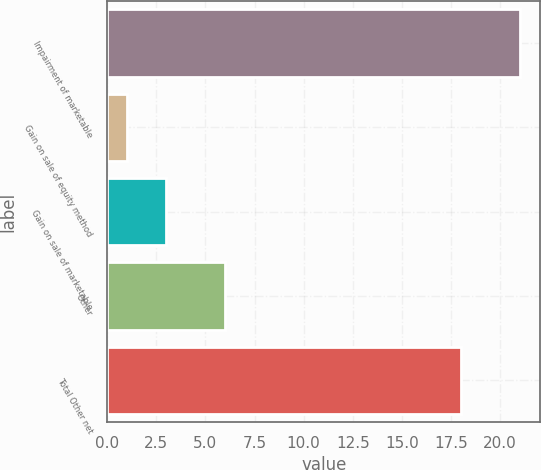Convert chart to OTSL. <chart><loc_0><loc_0><loc_500><loc_500><bar_chart><fcel>Impairment of marketable<fcel>Gain on sale of equity method<fcel>Gain on sale of marketable<fcel>Other<fcel>Total Other net<nl><fcel>21<fcel>1<fcel>3<fcel>6<fcel>18<nl></chart> 